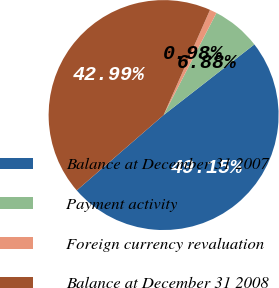Convert chart to OTSL. <chart><loc_0><loc_0><loc_500><loc_500><pie_chart><fcel>Balance at December 31 2007<fcel>Payment activity<fcel>Foreign currency revaluation<fcel>Balance at December 31 2008<nl><fcel>49.15%<fcel>6.88%<fcel>0.98%<fcel>42.99%<nl></chart> 